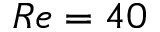Convert formula to latex. <formula><loc_0><loc_0><loc_500><loc_500>R e = 4 0</formula> 